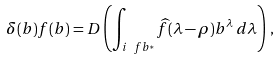<formula> <loc_0><loc_0><loc_500><loc_500>\delta ( b ) f ( b ) = D \left ( \int _ { i \ f b ^ { * } } \widehat { f } ( \lambda - \rho ) b ^ { \lambda } \, d \lambda \right ) \, ,</formula> 